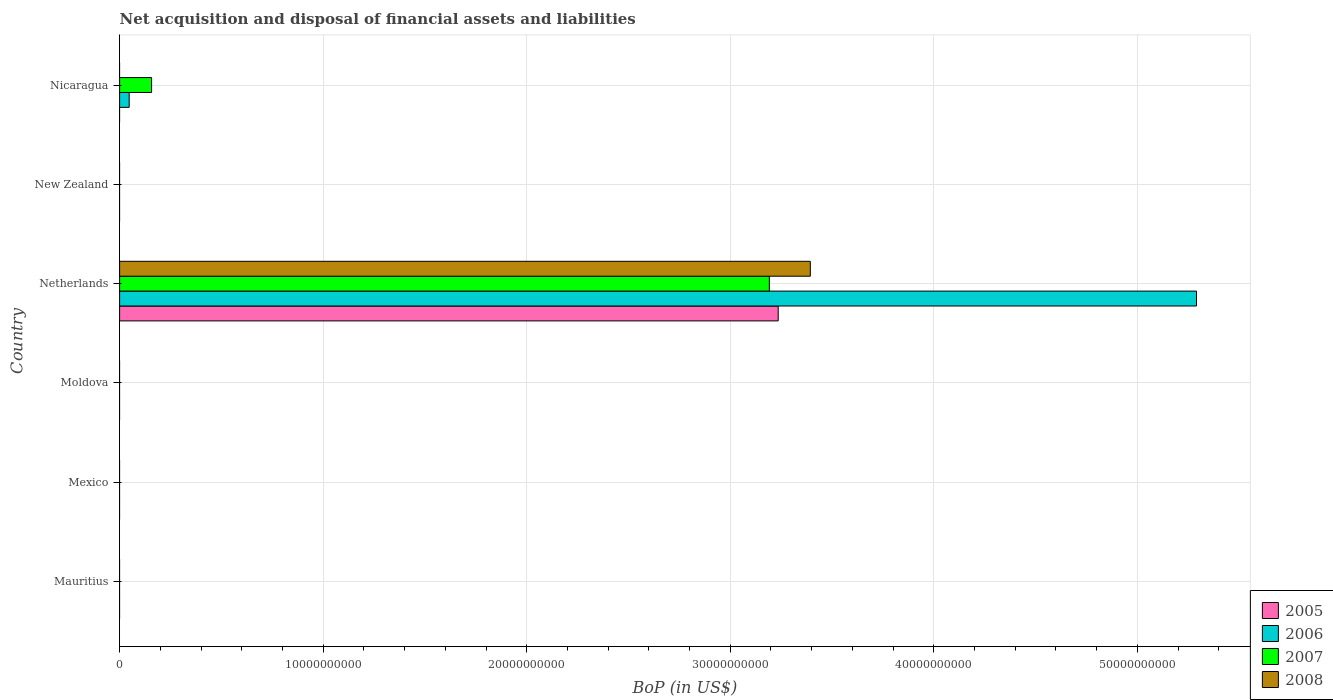How many different coloured bars are there?
Provide a succinct answer. 4. Are the number of bars per tick equal to the number of legend labels?
Make the answer very short. No. Are the number of bars on each tick of the Y-axis equal?
Provide a short and direct response. No. How many bars are there on the 5th tick from the top?
Keep it short and to the point. 0. What is the label of the 4th group of bars from the top?
Your answer should be very brief. Moldova. In how many cases, is the number of bars for a given country not equal to the number of legend labels?
Your answer should be very brief. 5. What is the Balance of Payments in 2006 in Netherlands?
Give a very brief answer. 5.29e+1. Across all countries, what is the maximum Balance of Payments in 2007?
Provide a short and direct response. 3.19e+1. Across all countries, what is the minimum Balance of Payments in 2007?
Give a very brief answer. 0. In which country was the Balance of Payments in 2007 maximum?
Offer a very short reply. Netherlands. What is the total Balance of Payments in 2005 in the graph?
Your answer should be very brief. 3.24e+1. What is the difference between the Balance of Payments in 2006 in Netherlands and that in Nicaragua?
Offer a very short reply. 5.24e+1. What is the difference between the Balance of Payments in 2006 in Moldova and the Balance of Payments in 2008 in Nicaragua?
Give a very brief answer. 0. What is the average Balance of Payments in 2008 per country?
Ensure brevity in your answer.  5.66e+09. What is the difference between the Balance of Payments in 2008 and Balance of Payments in 2005 in Netherlands?
Keep it short and to the point. 1.58e+09. What is the difference between the highest and the lowest Balance of Payments in 2005?
Give a very brief answer. 3.24e+1. In how many countries, is the Balance of Payments in 2008 greater than the average Balance of Payments in 2008 taken over all countries?
Offer a terse response. 1. Are all the bars in the graph horizontal?
Keep it short and to the point. Yes. How many countries are there in the graph?
Keep it short and to the point. 6. What is the difference between two consecutive major ticks on the X-axis?
Ensure brevity in your answer.  1.00e+1. Are the values on the major ticks of X-axis written in scientific E-notation?
Provide a short and direct response. No. Does the graph contain grids?
Keep it short and to the point. Yes. What is the title of the graph?
Your answer should be compact. Net acquisition and disposal of financial assets and liabilities. What is the label or title of the X-axis?
Offer a terse response. BoP (in US$). What is the BoP (in US$) in 2007 in Mauritius?
Make the answer very short. 0. What is the BoP (in US$) of 2008 in Mauritius?
Make the answer very short. 0. What is the BoP (in US$) of 2008 in Mexico?
Ensure brevity in your answer.  0. What is the BoP (in US$) in 2008 in Moldova?
Ensure brevity in your answer.  0. What is the BoP (in US$) of 2005 in Netherlands?
Your answer should be compact. 3.24e+1. What is the BoP (in US$) of 2006 in Netherlands?
Offer a very short reply. 5.29e+1. What is the BoP (in US$) in 2007 in Netherlands?
Provide a short and direct response. 3.19e+1. What is the BoP (in US$) in 2008 in Netherlands?
Make the answer very short. 3.39e+1. What is the BoP (in US$) in 2005 in New Zealand?
Provide a succinct answer. 0. What is the BoP (in US$) of 2006 in New Zealand?
Offer a very short reply. 0. What is the BoP (in US$) of 2007 in New Zealand?
Offer a very short reply. 0. What is the BoP (in US$) of 2008 in New Zealand?
Provide a succinct answer. 0. What is the BoP (in US$) of 2006 in Nicaragua?
Offer a terse response. 4.71e+08. What is the BoP (in US$) of 2007 in Nicaragua?
Provide a short and direct response. 1.57e+09. Across all countries, what is the maximum BoP (in US$) in 2005?
Your response must be concise. 3.24e+1. Across all countries, what is the maximum BoP (in US$) in 2006?
Make the answer very short. 5.29e+1. Across all countries, what is the maximum BoP (in US$) of 2007?
Ensure brevity in your answer.  3.19e+1. Across all countries, what is the maximum BoP (in US$) in 2008?
Offer a very short reply. 3.39e+1. Across all countries, what is the minimum BoP (in US$) in 2006?
Your answer should be very brief. 0. Across all countries, what is the minimum BoP (in US$) of 2008?
Offer a very short reply. 0. What is the total BoP (in US$) of 2005 in the graph?
Keep it short and to the point. 3.24e+1. What is the total BoP (in US$) in 2006 in the graph?
Give a very brief answer. 5.34e+1. What is the total BoP (in US$) of 2007 in the graph?
Provide a short and direct response. 3.35e+1. What is the total BoP (in US$) of 2008 in the graph?
Make the answer very short. 3.39e+1. What is the difference between the BoP (in US$) of 2006 in Netherlands and that in Nicaragua?
Offer a very short reply. 5.24e+1. What is the difference between the BoP (in US$) in 2007 in Netherlands and that in Nicaragua?
Provide a succinct answer. 3.03e+1. What is the difference between the BoP (in US$) of 2005 in Netherlands and the BoP (in US$) of 2006 in Nicaragua?
Give a very brief answer. 3.19e+1. What is the difference between the BoP (in US$) of 2005 in Netherlands and the BoP (in US$) of 2007 in Nicaragua?
Offer a very short reply. 3.08e+1. What is the difference between the BoP (in US$) in 2006 in Netherlands and the BoP (in US$) in 2007 in Nicaragua?
Your answer should be very brief. 5.13e+1. What is the average BoP (in US$) in 2005 per country?
Your response must be concise. 5.39e+09. What is the average BoP (in US$) of 2006 per country?
Your answer should be compact. 8.90e+09. What is the average BoP (in US$) of 2007 per country?
Keep it short and to the point. 5.58e+09. What is the average BoP (in US$) in 2008 per country?
Keep it short and to the point. 5.66e+09. What is the difference between the BoP (in US$) of 2005 and BoP (in US$) of 2006 in Netherlands?
Your answer should be very brief. -2.06e+1. What is the difference between the BoP (in US$) of 2005 and BoP (in US$) of 2007 in Netherlands?
Your answer should be very brief. 4.36e+08. What is the difference between the BoP (in US$) of 2005 and BoP (in US$) of 2008 in Netherlands?
Provide a succinct answer. -1.58e+09. What is the difference between the BoP (in US$) in 2006 and BoP (in US$) in 2007 in Netherlands?
Keep it short and to the point. 2.10e+1. What is the difference between the BoP (in US$) of 2006 and BoP (in US$) of 2008 in Netherlands?
Ensure brevity in your answer.  1.90e+1. What is the difference between the BoP (in US$) of 2007 and BoP (in US$) of 2008 in Netherlands?
Offer a terse response. -2.01e+09. What is the difference between the BoP (in US$) of 2006 and BoP (in US$) of 2007 in Nicaragua?
Your response must be concise. -1.10e+09. What is the ratio of the BoP (in US$) in 2006 in Netherlands to that in Nicaragua?
Your answer should be very brief. 112.4. What is the ratio of the BoP (in US$) of 2007 in Netherlands to that in Nicaragua?
Provide a succinct answer. 20.31. What is the difference between the highest and the lowest BoP (in US$) in 2005?
Your answer should be very brief. 3.24e+1. What is the difference between the highest and the lowest BoP (in US$) in 2006?
Your answer should be compact. 5.29e+1. What is the difference between the highest and the lowest BoP (in US$) of 2007?
Give a very brief answer. 3.19e+1. What is the difference between the highest and the lowest BoP (in US$) of 2008?
Provide a succinct answer. 3.39e+1. 